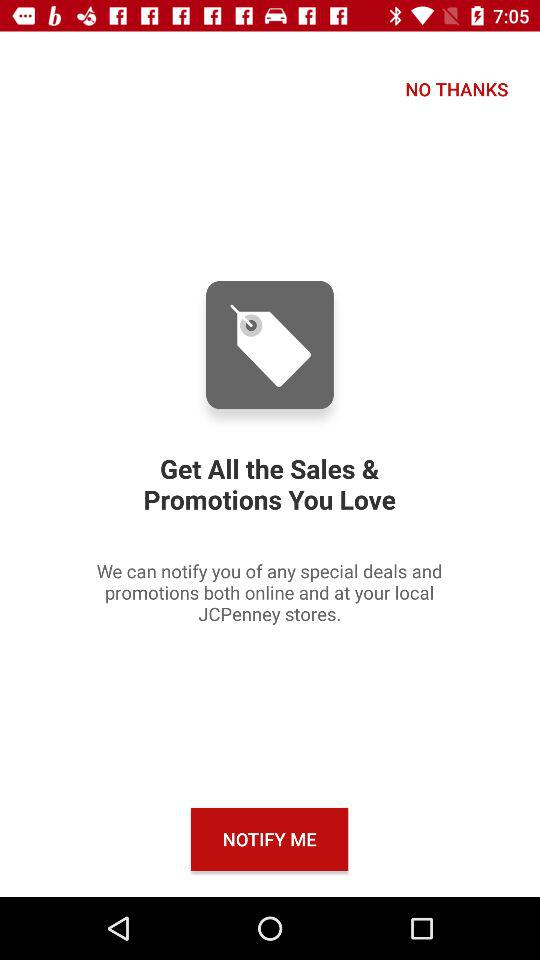What is the application name? The application name is "JCPenney". 